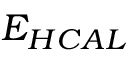<formula> <loc_0><loc_0><loc_500><loc_500>E _ { H C A L }</formula> 